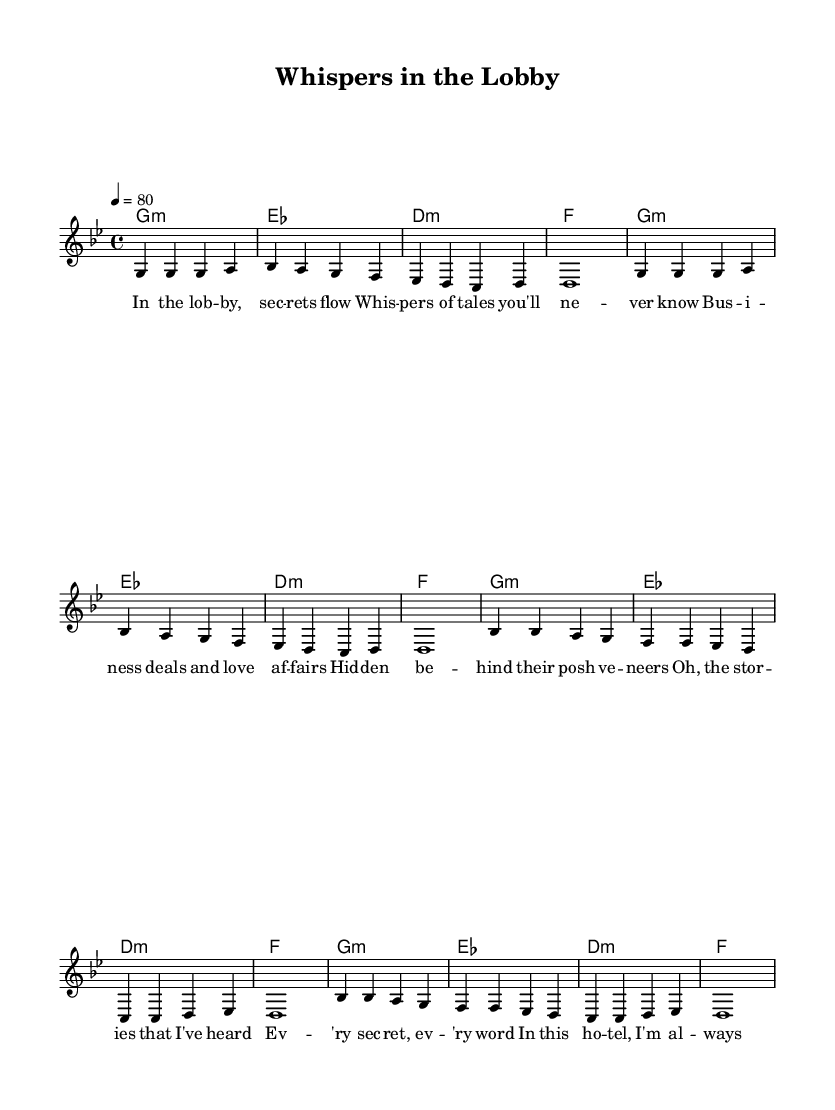What is the key signature of this music? The key signature shown is G minor, which has two flats (B flat and E flat). The presence of F sharp in the melody indicates it adheres to the harmonic minor scale.
Answer: G minor What is the time signature of this music? The time signature indicated at the beginning of the sheet music is 4/4, meaning there are four beats in each measure, and the quarter note gets one beat.
Answer: 4/4 What is the tempo marking for this music? The tempo is indicated as 4 beats per minute at a speed of 80. This suggests a moderate to slow pace, typical for reggae music.
Answer: 80 How many measures are in the verse section? The verse consists of two repeated sections made up of 8 measures total, divided into two sets of 4 measures each. Each line of music corresponds to a measure.
Answer: 8 What is the primary theme of the lyrics? The lyrics suggest a theme of secrets and stories overheard in hotel lobbies, capturing hidden lives and tales whispered among guests.
Answer: Secrets and stories How does the chorus relate to the verse? The chorus builds upon the themes introduced in the verse—specifically, the act of listening and observing, emphasizing the tales that are shared and heard, creating a cohesive narrative.
Answer: Cohesive narrative What type of harmony is predominantly used in this piece? The harmony is generally reflective of a minor tonality with the chords centered around G minor, creating a distinctively reggae sound that adds to the lyrical theme of mystery.
Answer: Minor tonality 